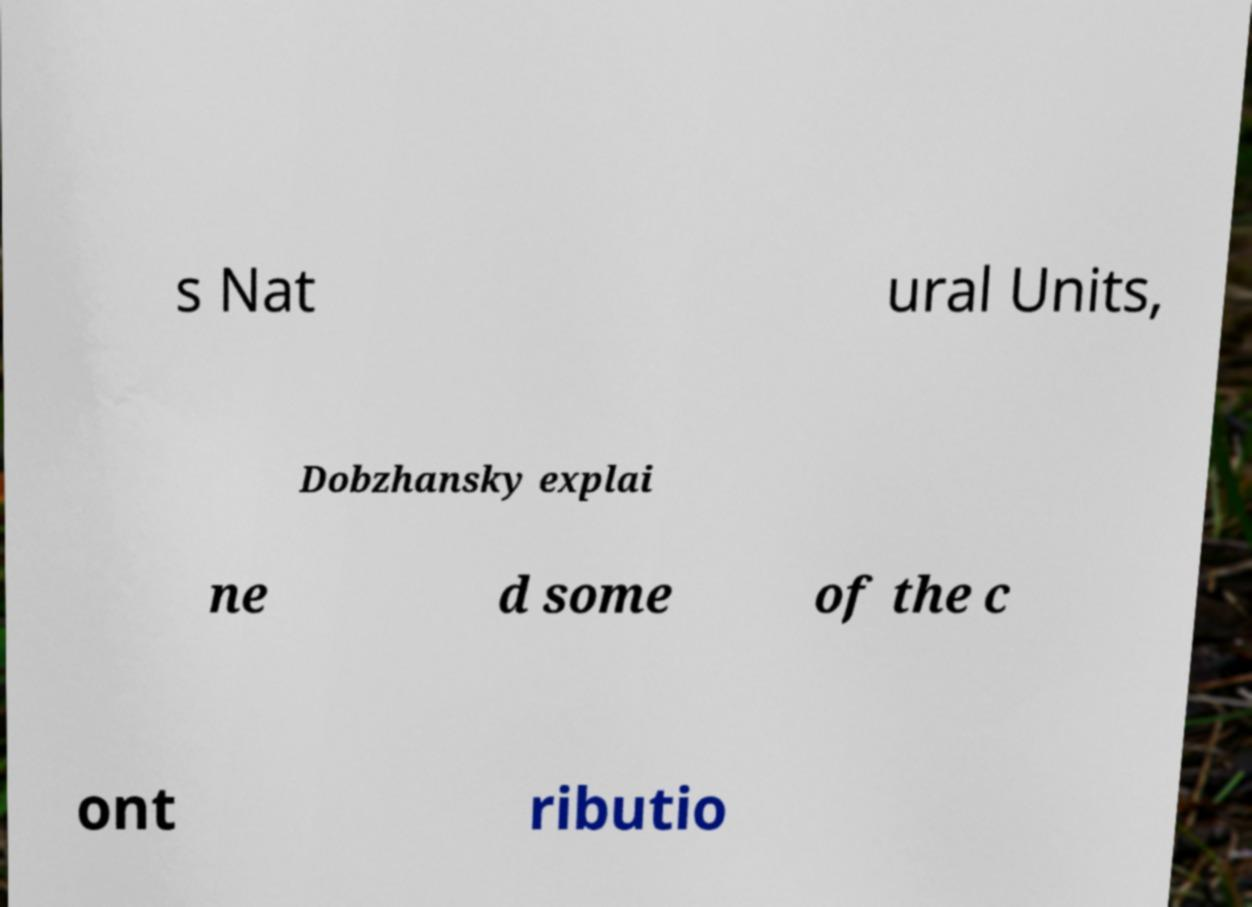What messages or text are displayed in this image? I need them in a readable, typed format. s Nat ural Units, Dobzhansky explai ne d some of the c ont ributio 